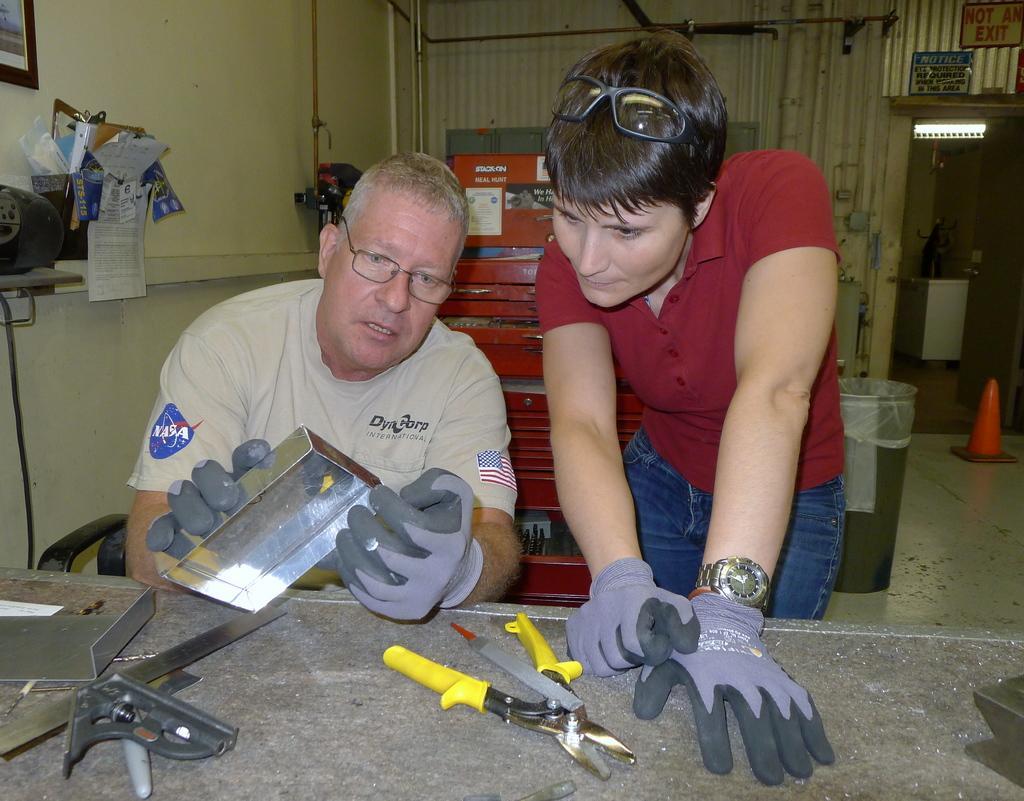In one or two sentences, can you explain what this image depicts? In this picture there is a person sitting and holding the object and there is a person standing. There are tools on the table. On the left side of the image there are objects on the table and there is a frame on the wall. At the back there is an object and there is a dustbin. On the right side of the image there is a door. At the top there is a light. 